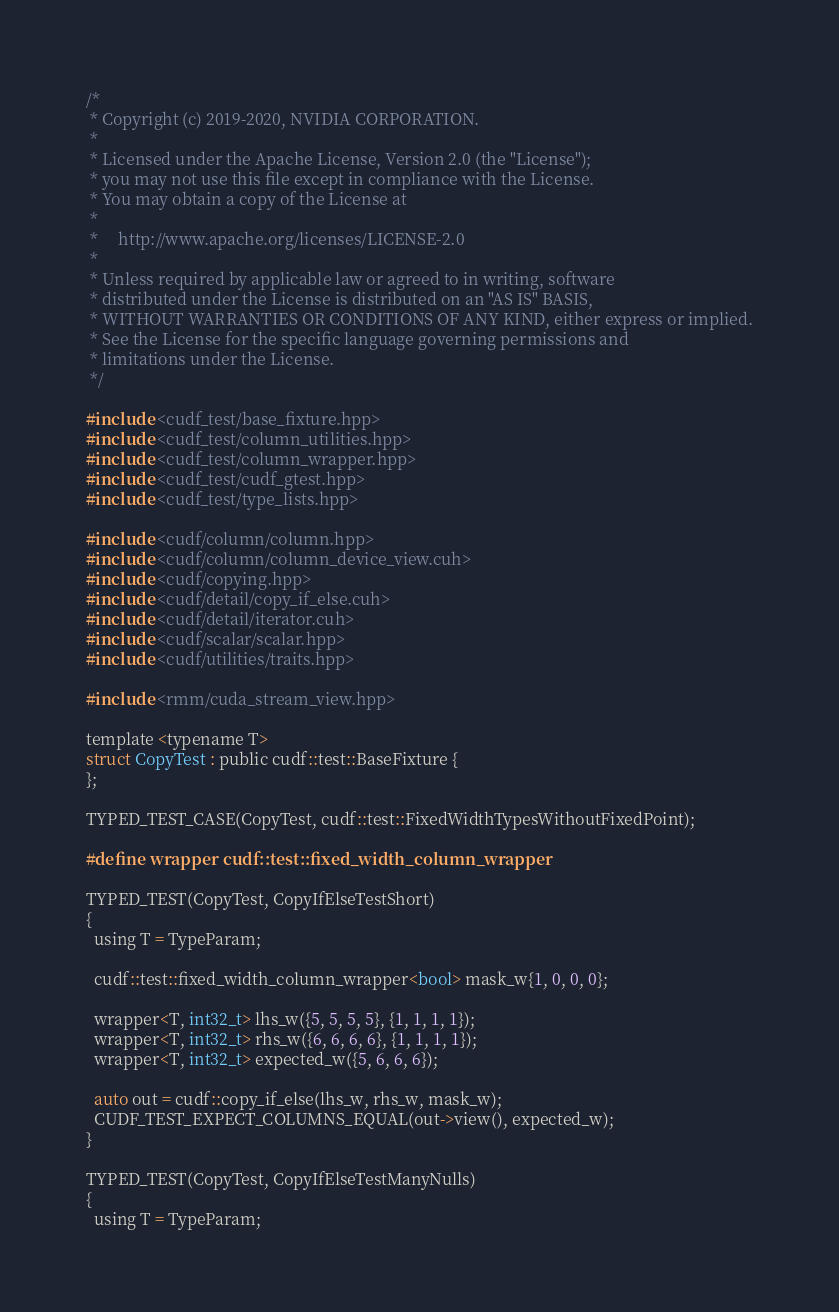<code> <loc_0><loc_0><loc_500><loc_500><_Cuda_>/*
 * Copyright (c) 2019-2020, NVIDIA CORPORATION.
 *
 * Licensed under the Apache License, Version 2.0 (the "License");
 * you may not use this file except in compliance with the License.
 * You may obtain a copy of the License at
 *
 *     http://www.apache.org/licenses/LICENSE-2.0
 *
 * Unless required by applicable law or agreed to in writing, software
 * distributed under the License is distributed on an "AS IS" BASIS,
 * WITHOUT WARRANTIES OR CONDITIONS OF ANY KIND, either express or implied.
 * See the License for the specific language governing permissions and
 * limitations under the License.
 */

#include <cudf_test/base_fixture.hpp>
#include <cudf_test/column_utilities.hpp>
#include <cudf_test/column_wrapper.hpp>
#include <cudf_test/cudf_gtest.hpp>
#include <cudf_test/type_lists.hpp>

#include <cudf/column/column.hpp>
#include <cudf/column/column_device_view.cuh>
#include <cudf/copying.hpp>
#include <cudf/detail/copy_if_else.cuh>
#include <cudf/detail/iterator.cuh>
#include <cudf/scalar/scalar.hpp>
#include <cudf/utilities/traits.hpp>

#include <rmm/cuda_stream_view.hpp>

template <typename T>
struct CopyTest : public cudf::test::BaseFixture {
};

TYPED_TEST_CASE(CopyTest, cudf::test::FixedWidthTypesWithoutFixedPoint);

#define wrapper cudf::test::fixed_width_column_wrapper

TYPED_TEST(CopyTest, CopyIfElseTestShort)
{
  using T = TypeParam;

  cudf::test::fixed_width_column_wrapper<bool> mask_w{1, 0, 0, 0};

  wrapper<T, int32_t> lhs_w({5, 5, 5, 5}, {1, 1, 1, 1});
  wrapper<T, int32_t> rhs_w({6, 6, 6, 6}, {1, 1, 1, 1});
  wrapper<T, int32_t> expected_w({5, 6, 6, 6});

  auto out = cudf::copy_if_else(lhs_w, rhs_w, mask_w);
  CUDF_TEST_EXPECT_COLUMNS_EQUAL(out->view(), expected_w);
}

TYPED_TEST(CopyTest, CopyIfElseTestManyNulls)
{
  using T = TypeParam;
</code> 